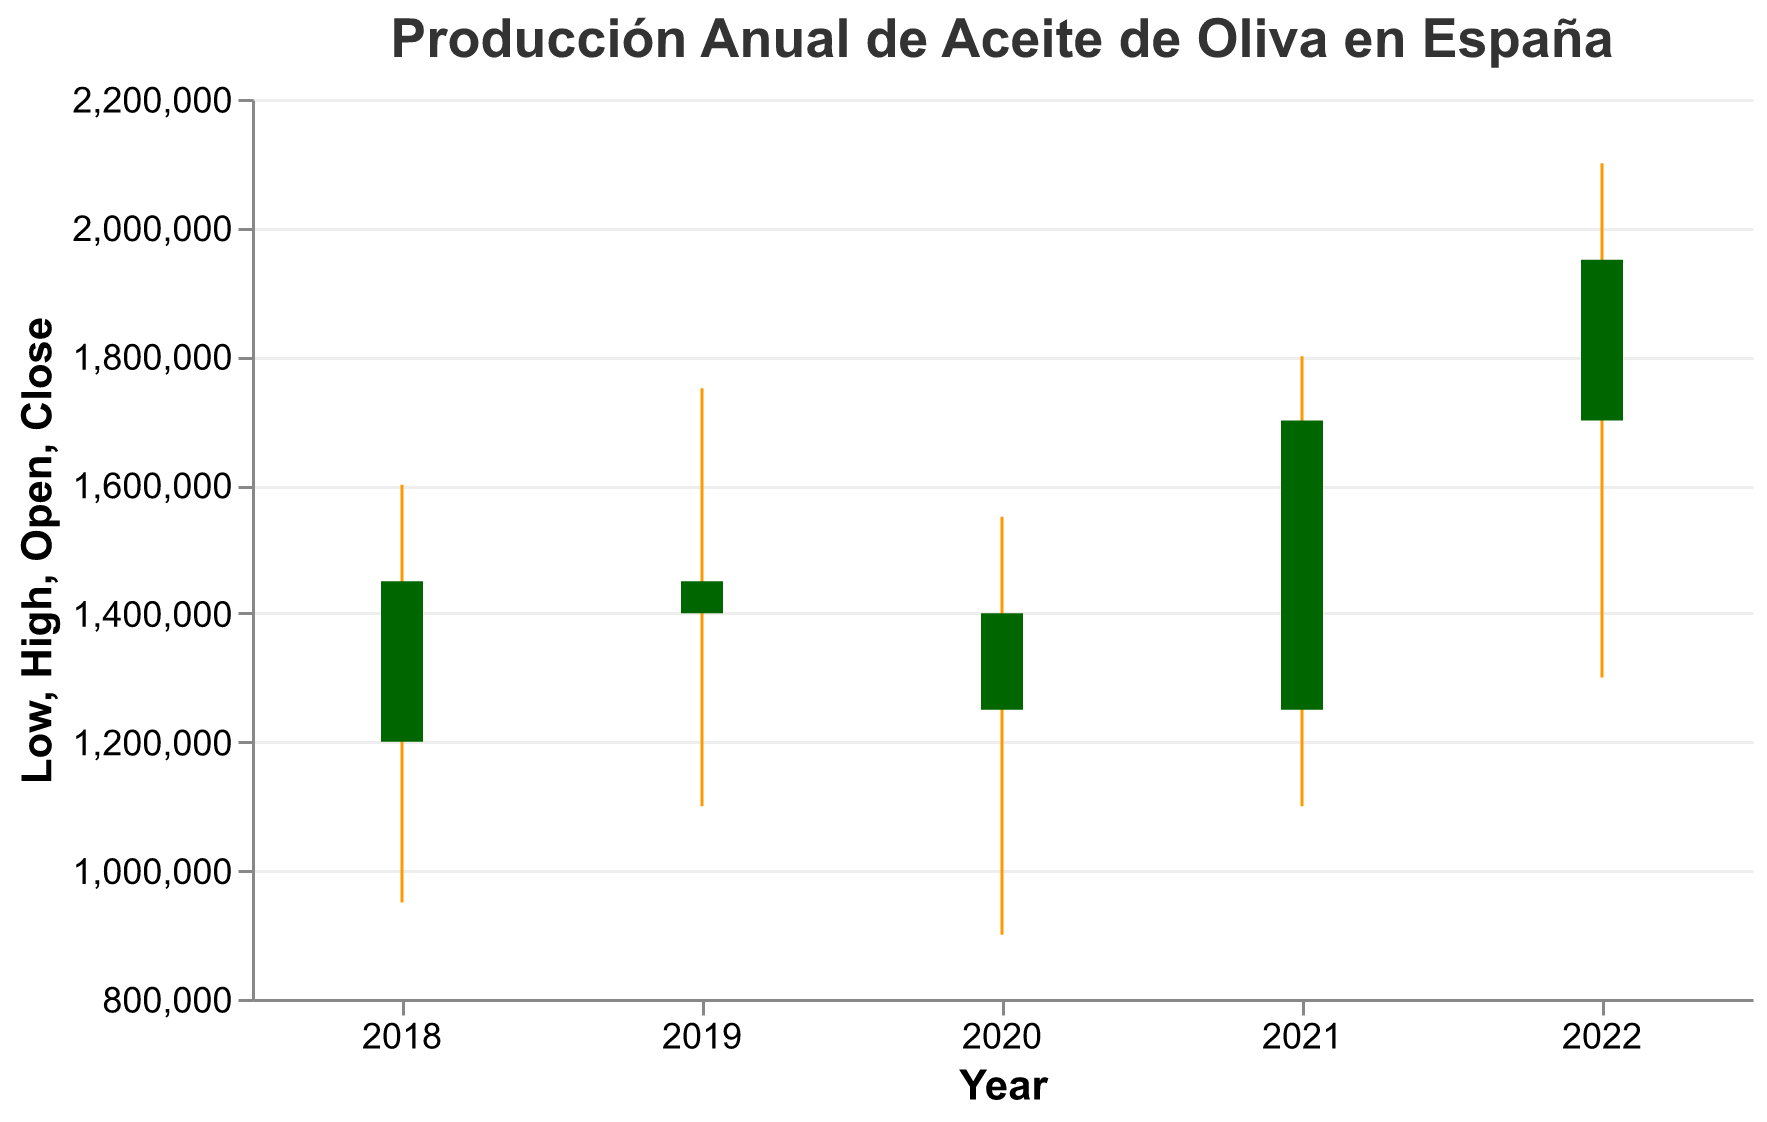¿Cuál es el valor más alto de producción de aceite de oliva en el año 2022? En el gráfico, se puede observar que el valor más alto de producción para el año 2022 está marcado como "High" en el eje y. Este valor es 2100000.
Answer: 2100000 ¿Cuál fue el valor de producción más bajo en el año 2020? En el gráfico, el valor más bajo está indicado por el punto donde la regla vertical toca el eje y, correspondiente a "Low". En el año 2020, este valor es 900000.
Answer: 900000 ¿Cómo varió la producción de aceite de oliva desde el comienzo hasta el final del año 2018? Para el año 2018, el valor de producción al comienzo (Open) fue 1200000 y al final (Close) fue 1450000. La diferencia entre estos valores es 1450000 - 1200000.
Answer: Aumentó en 250000 ¿Cuál año tuvo la mayor variación en la producción de aceite de oliva? La mayor variación se encuentra calculando la diferencia entre los valores de "High" y "Low" para cada año. El año con la mayor diferencia será el que tiene la mayor variación. La diferencia para cada año es: 2018 (1600000 - 950000 = 650000), 2019 (1750000 - 1100000 = 650000), 2020 (1550000 - 900000 = 650000), 2021 (1800000 - 1100000 = 700000), 2022 (2100000 - 1300000 = 800000).
Answer: 2022 ¿Cómo fue la producción de aceite de oliva en el año 2021 comparada con el año 2019 al final del año? El valor de producción al final del año (Close) para 2021 fue 1700000 y para 2019 fue 1400000. Comparando ambos valores: 1700000 > 1400000.
Answer: Fue mayor ¿Cuál es la tendencia general de la producción de aceite de oliva desde el 2018 al 2022? Analizando los valores de "Open" del 2018 al 2022, se puede ver que hay un aumento general en la producción inicial: 2018 (1200000), 2019 (1450000), 2020 (1400000), 2021 (1250000), 2022 (1700000).
Answer: Tendencia al aumento ¿En qué año fue la producción al final del año más baja? El valor de producción al final del año más bajo (Close) se puede observar al comparar todos los años. El valor más bajo es 1250000 en el año 2020.
Answer: 2020 Compare la diferencia entre los valores de producción al comienzo y al final del año 2019 y 2021. ¿Cuál tuvo la mayor diferencia? Para 2019, la diferencia es 1400000 - 1450000 = -50000. Para 2021, la diferencia es 1700000 - 1250000 = 450000. La diferencia mayor es en 2021.
Answer: 2021 ¿Cuál fue el año con la menor variación en la producción de aceite de oliva? Se debe calcular la diferencia entre "High" y "Low" para cada año. La diferencia menor será la menor variación. La diferencia para cada año: 2018 (650000), 2019 (650000), 2020 (650000), 2021 (700000), 2022 (800000).
Answer: 2018, 2019, 2020 (igual variación) 